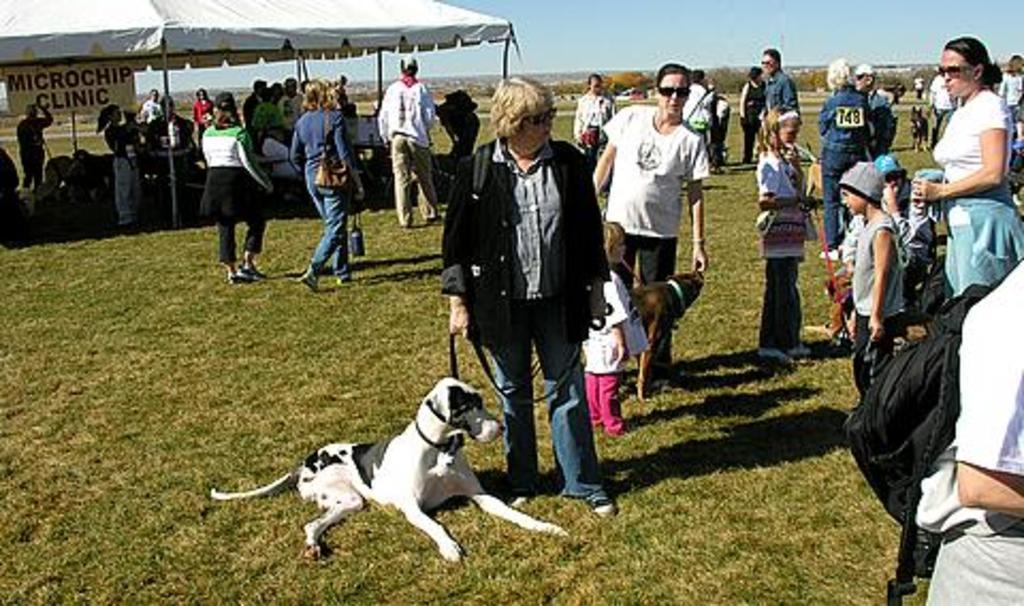Who or what can be seen in the image? There is a woman and a dog in the image. What are the woman and the dog doing? The woman and the dog are walking. What is the surface they are walking on? The floor is made of grass. Can you tell me what the judge is saying in the image? There is no judge present in the image. What type of line can be seen connecting the woman and the dog in the image? There is no line connecting the woman and the dog in the image. 